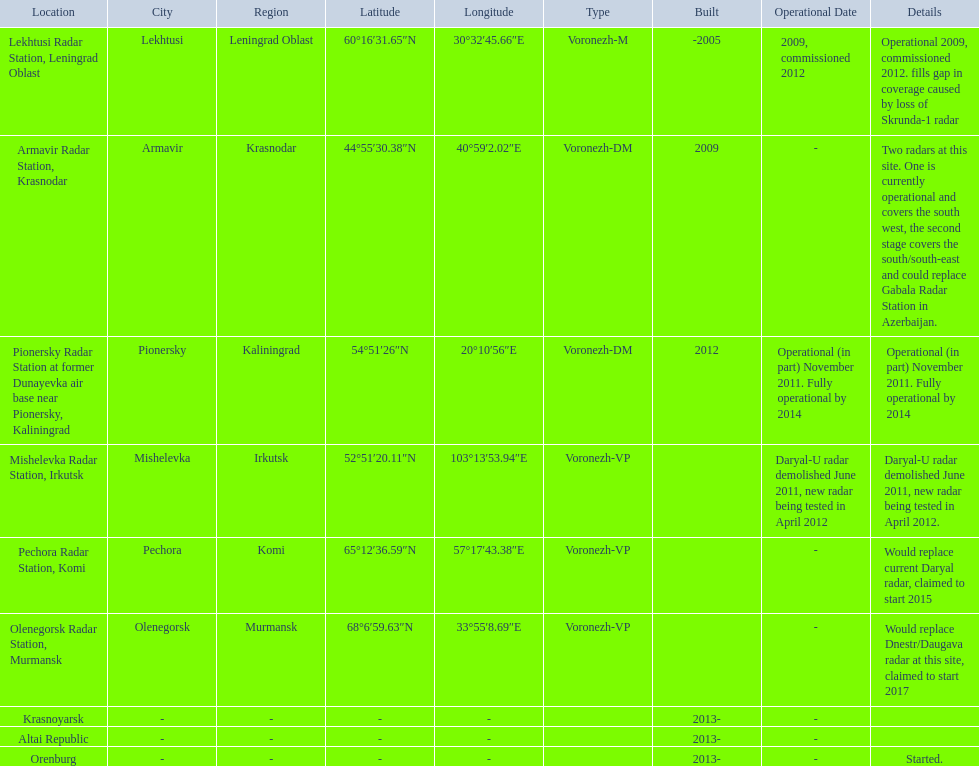Which column has the coordinates starting with 60 deg? 60°16′31.65″N 30°32′45.66″E﻿ / ﻿60.2754583°N 30.5460167°E. What is the location in the same row as that column? Lekhtusi Radar Station, Leningrad Oblast. Could you parse the entire table as a dict? {'header': ['Location', 'City', 'Region', 'Latitude', 'Longitude', 'Type', 'Built', 'Operational Date', 'Details'], 'rows': [['Lekhtusi Radar Station, Leningrad Oblast', 'Lekhtusi', 'Leningrad Oblast', '60°16′31.65″N', '30°32′45.66″E', 'Voronezh-M', '-2005', '2009, commissioned 2012', 'Operational 2009, commissioned 2012. fills gap in coverage caused by loss of Skrunda-1 radar'], ['Armavir Radar Station, Krasnodar', 'Armavir', 'Krasnodar', '44°55′30.38″N', '40°59′2.02″E', 'Voronezh-DM', '2009', '-', 'Two radars at this site. One is currently operational and covers the south west, the second stage covers the south/south-east and could replace Gabala Radar Station in Azerbaijan.'], ['Pionersky Radar Station at former Dunayevka air base near Pionersky, Kaliningrad', 'Pionersky', 'Kaliningrad', '54°51′26″N', '20°10′56″E', 'Voronezh-DM', '2012', 'Operational (in part) November 2011. Fully operational by 2014', 'Operational (in part) November 2011. Fully operational by 2014'], ['Mishelevka Radar Station, Irkutsk', 'Mishelevka', 'Irkutsk', '52°51′20.11″N', '103°13′53.94″E', 'Voronezh-VP', '', 'Daryal-U radar demolished June 2011, new radar being tested in April 2012', 'Daryal-U radar demolished June 2011, new radar being tested in April 2012.'], ['Pechora Radar Station, Komi', 'Pechora', 'Komi', '65°12′36.59″N', '57°17′43.38″E', 'Voronezh-VP', '', '-', 'Would replace current Daryal radar, claimed to start 2015'], ['Olenegorsk Radar Station, Murmansk', 'Olenegorsk', 'Murmansk', '68°6′59.63″N', '33°55′8.69″E', 'Voronezh-VP', '', '-', 'Would replace Dnestr/Daugava radar at this site, claimed to start 2017'], ['Krasnoyarsk', '-', '-', '-', '-', '', '2013-', '-', ''], ['Altai Republic', '-', '-', '-', '-', '', '2013-', '-', ''], ['Orenburg', '-', '-', '-', '-', '', '2013-', '-', 'Started.']]} 